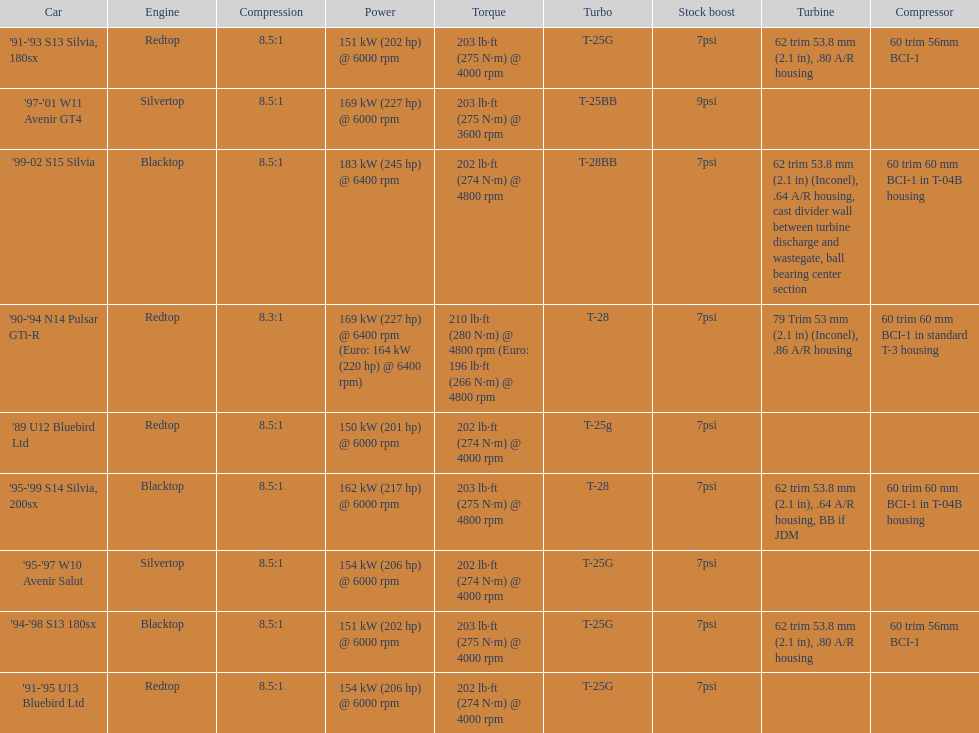Parse the table in full. {'header': ['Car', 'Engine', 'Compression', 'Power', 'Torque', 'Turbo', 'Stock boost', 'Turbine', 'Compressor'], 'rows': [["'91-'93 S13 Silvia, 180sx", 'Redtop', '8.5:1', '151\xa0kW (202\xa0hp) @ 6000 rpm', '203\xa0lb·ft (275\xa0N·m) @ 4000 rpm', 'T-25G', '7psi', '62 trim 53.8\xa0mm (2.1\xa0in), .80 A/R housing', '60 trim 56mm BCI-1'], ["'97-'01 W11 Avenir GT4", 'Silvertop', '8.5:1', '169\xa0kW (227\xa0hp) @ 6000 rpm', '203\xa0lb·ft (275\xa0N·m) @ 3600 rpm', 'T-25BB', '9psi', '', ''], ["'99-02 S15 Silvia", 'Blacktop', '8.5:1', '183\xa0kW (245\xa0hp) @ 6400 rpm', '202\xa0lb·ft (274\xa0N·m) @ 4800 rpm', 'T-28BB', '7psi', '62 trim 53.8\xa0mm (2.1\xa0in) (Inconel), .64 A/R housing, cast divider wall between turbine discharge and wastegate, ball bearing center section', '60 trim 60\xa0mm BCI-1 in T-04B housing'], ["'90-'94 N14 Pulsar GTi-R", 'Redtop', '8.3:1', '169\xa0kW (227\xa0hp) @ 6400 rpm (Euro: 164\xa0kW (220\xa0hp) @ 6400 rpm)', '210\xa0lb·ft (280\xa0N·m) @ 4800 rpm (Euro: 196\xa0lb·ft (266\xa0N·m) @ 4800 rpm', 'T-28', '7psi', '79 Trim 53\xa0mm (2.1\xa0in) (Inconel), .86 A/R housing', '60 trim 60\xa0mm BCI-1 in standard T-3 housing'], ["'89 U12 Bluebird Ltd", 'Redtop', '8.5:1', '150\xa0kW (201\xa0hp) @ 6000 rpm', '202\xa0lb·ft (274\xa0N·m) @ 4000 rpm', 'T-25g', '7psi', '', ''], ["'95-'99 S14 Silvia, 200sx", 'Blacktop', '8.5:1', '162\xa0kW (217\xa0hp) @ 6000 rpm', '203\xa0lb·ft (275\xa0N·m) @ 4800 rpm', 'T-28', '7psi', '62 trim 53.8\xa0mm (2.1\xa0in), .64 A/R housing, BB if JDM', '60 trim 60\xa0mm BCI-1 in T-04B housing'], ["'95-'97 W10 Avenir Salut", 'Silvertop', '8.5:1', '154\xa0kW (206\xa0hp) @ 6000 rpm', '202\xa0lb·ft (274\xa0N·m) @ 4000 rpm', 'T-25G', '7psi', '', ''], ["'94-'98 S13 180sx", 'Blacktop', '8.5:1', '151\xa0kW (202\xa0hp) @ 6000 rpm', '203\xa0lb·ft (275\xa0N·m) @ 4000 rpm', 'T-25G', '7psi', '62 trim 53.8\xa0mm (2.1\xa0in), .80 A/R housing', '60 trim 56mm BCI-1'], ["'91-'95 U13 Bluebird Ltd", 'Redtop', '8.5:1', '154\xa0kW (206\xa0hp) @ 6000 rpm', '202\xa0lb·ft (274\xa0N·m) @ 4000 rpm', 'T-25G', '7psi', '', '']]} What is his/her compression for the 90-94 n14 pulsar gti-r? 8.3:1. 